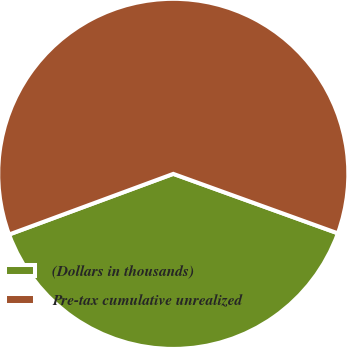<chart> <loc_0><loc_0><loc_500><loc_500><pie_chart><fcel>(Dollars in thousands)<fcel>Pre-tax cumulative unrealized<nl><fcel>38.85%<fcel>61.15%<nl></chart> 